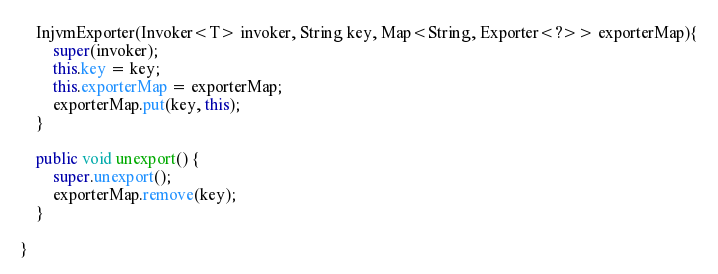<code> <loc_0><loc_0><loc_500><loc_500><_Java_>    InjvmExporter(Invoker<T> invoker, String key, Map<String, Exporter<?>> exporterMap){
        super(invoker);
        this.key = key;
        this.exporterMap = exporterMap;
        exporterMap.put(key, this);
    }

    public void unexport() {
        super.unexport();
        exporterMap.remove(key);
    }

}</code> 